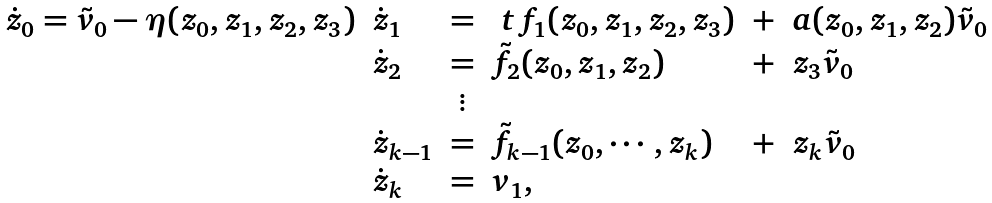<formula> <loc_0><loc_0><loc_500><loc_500>\begin{array} { l l c l c l } \dot { z } _ { 0 } = \tilde { v } _ { 0 } - \eta ( z _ { 0 } , z _ { 1 } , z _ { 2 } , z _ { 3 } ) & \dot { z } _ { 1 } & = & \ t { f } _ { 1 } ( z _ { 0 } , z _ { 1 } , z _ { 2 } , z _ { 3 } ) & + & a ( z _ { 0 } , z _ { 1 } , z _ { 2 } ) \tilde { v } _ { 0 } \\ & \dot { z } _ { 2 } & = & \tilde { f } _ { 2 } ( z _ { 0 } , z _ { 1 } , z _ { 2 } ) & + & z _ { 3 } \tilde { v } _ { 0 } \\ & & \vdots & & & \\ & \dot { z } _ { k - 1 } & = & \tilde { f } _ { k - 1 } ( z _ { 0 } , \cdots , z _ { k } ) & + & z _ { k } \tilde { v } _ { 0 } \\ & \dot { z } _ { k } & = & v _ { 1 } , & & \end{array}</formula> 